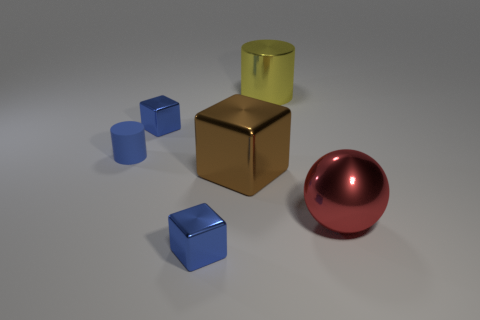There is a red sphere that is in front of the tiny blue cylinder; is its size the same as the cylinder behind the small cylinder?
Offer a terse response. Yes. Are there any red metallic objects that have the same size as the yellow cylinder?
Offer a very short reply. Yes. Is the shape of the blue object that is in front of the big brown shiny thing the same as  the brown object?
Provide a succinct answer. Yes. What material is the tiny blue cube that is in front of the red metallic ball?
Your answer should be very brief. Metal. The small shiny object behind the red object to the right of the brown metallic thing is what shape?
Ensure brevity in your answer.  Cube. There is a yellow metallic thing; does it have the same shape as the small rubber thing in front of the big cylinder?
Provide a short and direct response. Yes. What number of small blue metallic things are on the left side of the small blue cube that is in front of the large red object?
Keep it short and to the point. 1. There is a yellow object that is the same shape as the blue matte thing; what is its material?
Your answer should be compact. Metal. How many blue things are tiny cylinders or tiny cubes?
Offer a terse response. 3. Are there any other things that have the same color as the large ball?
Offer a terse response. No. 